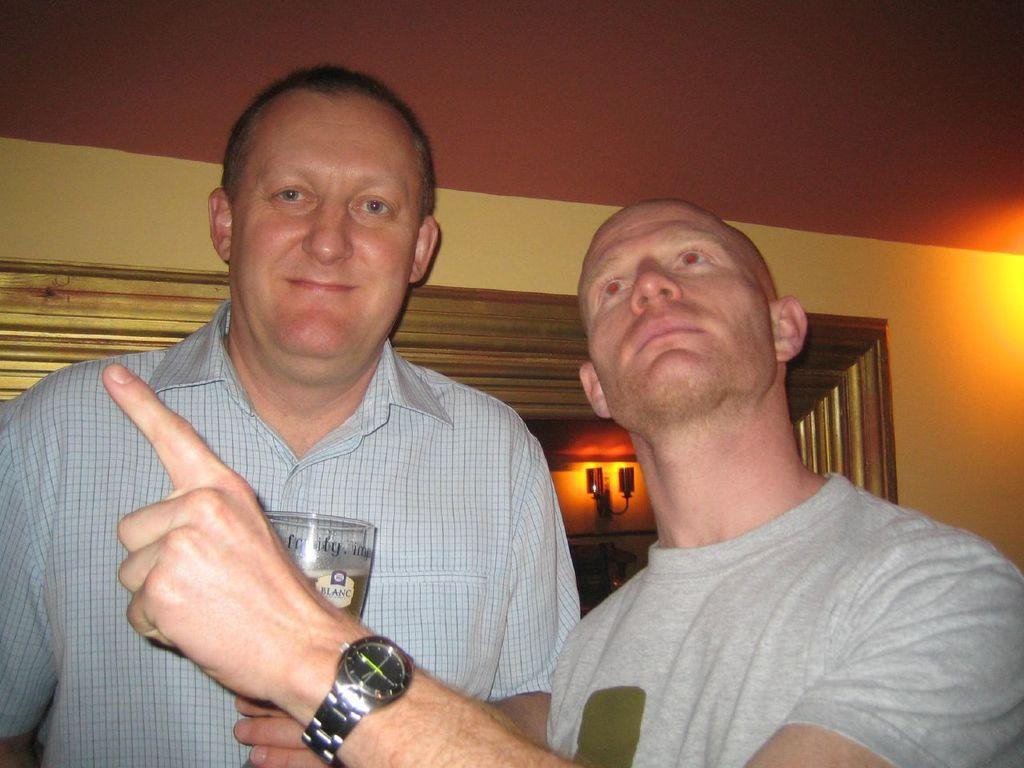How many people are in the image? There are two men in the image. What are the men doing in the image? The men are standing in front and holding wine glasses. Can you see any jellyfish in the image? No, there are no jellyfish present in the image. 